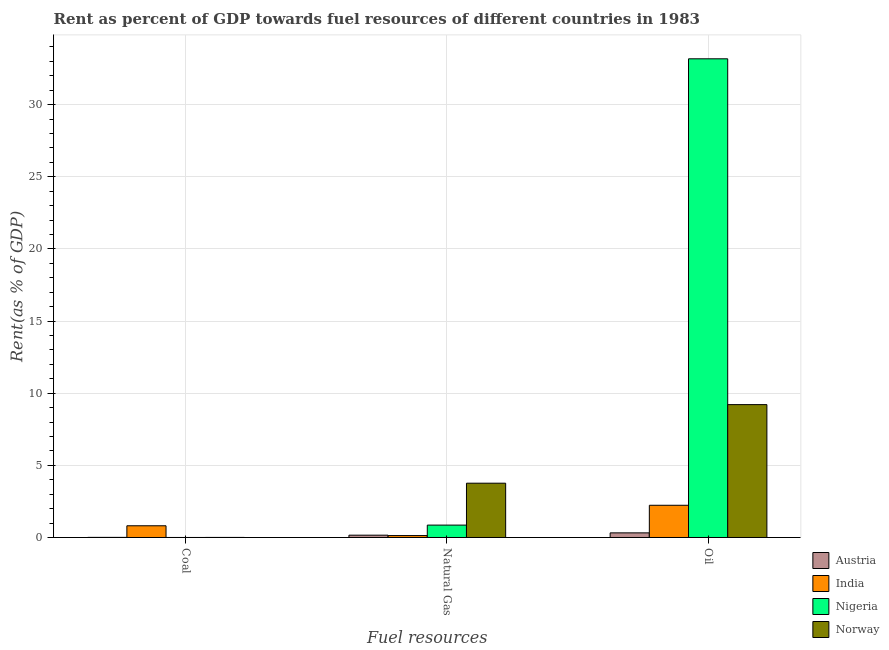How many different coloured bars are there?
Ensure brevity in your answer.  4. How many groups of bars are there?
Offer a terse response. 3. Are the number of bars per tick equal to the number of legend labels?
Your answer should be compact. Yes. How many bars are there on the 3rd tick from the left?
Make the answer very short. 4. What is the label of the 2nd group of bars from the left?
Your answer should be very brief. Natural Gas. What is the rent towards natural gas in Nigeria?
Your response must be concise. 0.86. Across all countries, what is the maximum rent towards coal?
Ensure brevity in your answer.  0.81. Across all countries, what is the minimum rent towards oil?
Give a very brief answer. 0.32. In which country was the rent towards oil maximum?
Offer a very short reply. Nigeria. What is the total rent towards natural gas in the graph?
Offer a very short reply. 4.91. What is the difference between the rent towards natural gas in Austria and that in Nigeria?
Provide a short and direct response. -0.7. What is the difference between the rent towards natural gas in Norway and the rent towards oil in Nigeria?
Give a very brief answer. -29.41. What is the average rent towards oil per country?
Keep it short and to the point. 11.23. What is the difference between the rent towards coal and rent towards natural gas in India?
Give a very brief answer. 0.68. In how many countries, is the rent towards oil greater than 32 %?
Provide a succinct answer. 1. What is the ratio of the rent towards coal in Norway to that in Nigeria?
Offer a very short reply. 3.17. Is the difference between the rent towards coal in Norway and India greater than the difference between the rent towards natural gas in Norway and India?
Give a very brief answer. No. What is the difference between the highest and the second highest rent towards oil?
Offer a terse response. 23.96. What is the difference between the highest and the lowest rent towards coal?
Ensure brevity in your answer.  0.81. What does the 2nd bar from the right in Oil represents?
Ensure brevity in your answer.  Nigeria. Is it the case that in every country, the sum of the rent towards coal and rent towards natural gas is greater than the rent towards oil?
Your answer should be very brief. No. How many bars are there?
Make the answer very short. 12. Are all the bars in the graph horizontal?
Offer a very short reply. No. How many countries are there in the graph?
Ensure brevity in your answer.  4. Are the values on the major ticks of Y-axis written in scientific E-notation?
Your response must be concise. No. How many legend labels are there?
Offer a terse response. 4. What is the title of the graph?
Your answer should be very brief. Rent as percent of GDP towards fuel resources of different countries in 1983. What is the label or title of the X-axis?
Offer a terse response. Fuel resources. What is the label or title of the Y-axis?
Keep it short and to the point. Rent(as % of GDP). What is the Rent(as % of GDP) of Austria in Coal?
Keep it short and to the point. 0.01. What is the Rent(as % of GDP) in India in Coal?
Ensure brevity in your answer.  0.81. What is the Rent(as % of GDP) in Nigeria in Coal?
Give a very brief answer. 0. What is the Rent(as % of GDP) in Norway in Coal?
Keep it short and to the point. 0. What is the Rent(as % of GDP) in Austria in Natural Gas?
Your answer should be very brief. 0.16. What is the Rent(as % of GDP) in India in Natural Gas?
Make the answer very short. 0.13. What is the Rent(as % of GDP) in Nigeria in Natural Gas?
Offer a terse response. 0.86. What is the Rent(as % of GDP) of Norway in Natural Gas?
Provide a short and direct response. 3.76. What is the Rent(as % of GDP) of Austria in Oil?
Provide a short and direct response. 0.32. What is the Rent(as % of GDP) of India in Oil?
Provide a succinct answer. 2.23. What is the Rent(as % of GDP) of Nigeria in Oil?
Make the answer very short. 33.17. What is the Rent(as % of GDP) of Norway in Oil?
Your answer should be compact. 9.21. Across all Fuel resources, what is the maximum Rent(as % of GDP) of Austria?
Your response must be concise. 0.32. Across all Fuel resources, what is the maximum Rent(as % of GDP) of India?
Provide a succinct answer. 2.23. Across all Fuel resources, what is the maximum Rent(as % of GDP) in Nigeria?
Keep it short and to the point. 33.17. Across all Fuel resources, what is the maximum Rent(as % of GDP) of Norway?
Ensure brevity in your answer.  9.21. Across all Fuel resources, what is the minimum Rent(as % of GDP) in Austria?
Offer a very short reply. 0.01. Across all Fuel resources, what is the minimum Rent(as % of GDP) in India?
Provide a succinct answer. 0.13. Across all Fuel resources, what is the minimum Rent(as % of GDP) in Nigeria?
Your answer should be very brief. 0. Across all Fuel resources, what is the minimum Rent(as % of GDP) in Norway?
Give a very brief answer. 0. What is the total Rent(as % of GDP) in Austria in the graph?
Your answer should be very brief. 0.49. What is the total Rent(as % of GDP) of India in the graph?
Keep it short and to the point. 3.18. What is the total Rent(as % of GDP) of Nigeria in the graph?
Provide a short and direct response. 34.03. What is the total Rent(as % of GDP) in Norway in the graph?
Offer a very short reply. 12.98. What is the difference between the Rent(as % of GDP) of Austria in Coal and that in Natural Gas?
Provide a succinct answer. -0.15. What is the difference between the Rent(as % of GDP) in India in Coal and that in Natural Gas?
Your answer should be compact. 0.68. What is the difference between the Rent(as % of GDP) of Nigeria in Coal and that in Natural Gas?
Offer a terse response. -0.86. What is the difference between the Rent(as % of GDP) of Norway in Coal and that in Natural Gas?
Keep it short and to the point. -3.76. What is the difference between the Rent(as % of GDP) of Austria in Coal and that in Oil?
Your response must be concise. -0.31. What is the difference between the Rent(as % of GDP) of India in Coal and that in Oil?
Your answer should be very brief. -1.42. What is the difference between the Rent(as % of GDP) in Nigeria in Coal and that in Oil?
Give a very brief answer. -33.17. What is the difference between the Rent(as % of GDP) in Norway in Coal and that in Oil?
Offer a very short reply. -9.2. What is the difference between the Rent(as % of GDP) of Austria in Natural Gas and that in Oil?
Provide a short and direct response. -0.16. What is the difference between the Rent(as % of GDP) in India in Natural Gas and that in Oil?
Give a very brief answer. -2.1. What is the difference between the Rent(as % of GDP) of Nigeria in Natural Gas and that in Oil?
Make the answer very short. -32.31. What is the difference between the Rent(as % of GDP) in Norway in Natural Gas and that in Oil?
Provide a short and direct response. -5.45. What is the difference between the Rent(as % of GDP) of Austria in Coal and the Rent(as % of GDP) of India in Natural Gas?
Give a very brief answer. -0.13. What is the difference between the Rent(as % of GDP) of Austria in Coal and the Rent(as % of GDP) of Nigeria in Natural Gas?
Your answer should be compact. -0.85. What is the difference between the Rent(as % of GDP) of Austria in Coal and the Rent(as % of GDP) of Norway in Natural Gas?
Make the answer very short. -3.76. What is the difference between the Rent(as % of GDP) of India in Coal and the Rent(as % of GDP) of Nigeria in Natural Gas?
Your answer should be very brief. -0.05. What is the difference between the Rent(as % of GDP) in India in Coal and the Rent(as % of GDP) in Norway in Natural Gas?
Give a very brief answer. -2.95. What is the difference between the Rent(as % of GDP) of Nigeria in Coal and the Rent(as % of GDP) of Norway in Natural Gas?
Your answer should be very brief. -3.76. What is the difference between the Rent(as % of GDP) in Austria in Coal and the Rent(as % of GDP) in India in Oil?
Keep it short and to the point. -2.23. What is the difference between the Rent(as % of GDP) of Austria in Coal and the Rent(as % of GDP) of Nigeria in Oil?
Provide a succinct answer. -33.17. What is the difference between the Rent(as % of GDP) in Austria in Coal and the Rent(as % of GDP) in Norway in Oil?
Ensure brevity in your answer.  -9.2. What is the difference between the Rent(as % of GDP) of India in Coal and the Rent(as % of GDP) of Nigeria in Oil?
Make the answer very short. -32.36. What is the difference between the Rent(as % of GDP) of India in Coal and the Rent(as % of GDP) of Norway in Oil?
Your response must be concise. -8.4. What is the difference between the Rent(as % of GDP) of Nigeria in Coal and the Rent(as % of GDP) of Norway in Oil?
Offer a terse response. -9.21. What is the difference between the Rent(as % of GDP) in Austria in Natural Gas and the Rent(as % of GDP) in India in Oil?
Your response must be concise. -2.07. What is the difference between the Rent(as % of GDP) of Austria in Natural Gas and the Rent(as % of GDP) of Nigeria in Oil?
Offer a terse response. -33.01. What is the difference between the Rent(as % of GDP) in Austria in Natural Gas and the Rent(as % of GDP) in Norway in Oil?
Ensure brevity in your answer.  -9.05. What is the difference between the Rent(as % of GDP) of India in Natural Gas and the Rent(as % of GDP) of Nigeria in Oil?
Offer a terse response. -33.04. What is the difference between the Rent(as % of GDP) in India in Natural Gas and the Rent(as % of GDP) in Norway in Oil?
Your answer should be very brief. -9.08. What is the difference between the Rent(as % of GDP) of Nigeria in Natural Gas and the Rent(as % of GDP) of Norway in Oil?
Make the answer very short. -8.35. What is the average Rent(as % of GDP) in Austria per Fuel resources?
Offer a terse response. 0.16. What is the average Rent(as % of GDP) of India per Fuel resources?
Your response must be concise. 1.06. What is the average Rent(as % of GDP) of Nigeria per Fuel resources?
Your answer should be very brief. 11.34. What is the average Rent(as % of GDP) in Norway per Fuel resources?
Offer a very short reply. 4.33. What is the difference between the Rent(as % of GDP) of Austria and Rent(as % of GDP) of India in Coal?
Keep it short and to the point. -0.8. What is the difference between the Rent(as % of GDP) in Austria and Rent(as % of GDP) in Nigeria in Coal?
Ensure brevity in your answer.  0.01. What is the difference between the Rent(as % of GDP) in Austria and Rent(as % of GDP) in Norway in Coal?
Make the answer very short. 0. What is the difference between the Rent(as % of GDP) in India and Rent(as % of GDP) in Nigeria in Coal?
Give a very brief answer. 0.81. What is the difference between the Rent(as % of GDP) in India and Rent(as % of GDP) in Norway in Coal?
Make the answer very short. 0.81. What is the difference between the Rent(as % of GDP) of Nigeria and Rent(as % of GDP) of Norway in Coal?
Your response must be concise. -0. What is the difference between the Rent(as % of GDP) in Austria and Rent(as % of GDP) in India in Natural Gas?
Your response must be concise. 0.03. What is the difference between the Rent(as % of GDP) of Austria and Rent(as % of GDP) of Nigeria in Natural Gas?
Ensure brevity in your answer.  -0.7. What is the difference between the Rent(as % of GDP) of Austria and Rent(as % of GDP) of Norway in Natural Gas?
Keep it short and to the point. -3.6. What is the difference between the Rent(as % of GDP) in India and Rent(as % of GDP) in Nigeria in Natural Gas?
Your response must be concise. -0.73. What is the difference between the Rent(as % of GDP) in India and Rent(as % of GDP) in Norway in Natural Gas?
Ensure brevity in your answer.  -3.63. What is the difference between the Rent(as % of GDP) of Nigeria and Rent(as % of GDP) of Norway in Natural Gas?
Your answer should be very brief. -2.9. What is the difference between the Rent(as % of GDP) of Austria and Rent(as % of GDP) of India in Oil?
Keep it short and to the point. -1.91. What is the difference between the Rent(as % of GDP) of Austria and Rent(as % of GDP) of Nigeria in Oil?
Your response must be concise. -32.85. What is the difference between the Rent(as % of GDP) in Austria and Rent(as % of GDP) in Norway in Oil?
Ensure brevity in your answer.  -8.89. What is the difference between the Rent(as % of GDP) in India and Rent(as % of GDP) in Nigeria in Oil?
Offer a very short reply. -30.94. What is the difference between the Rent(as % of GDP) of India and Rent(as % of GDP) of Norway in Oil?
Provide a short and direct response. -6.98. What is the difference between the Rent(as % of GDP) in Nigeria and Rent(as % of GDP) in Norway in Oil?
Give a very brief answer. 23.96. What is the ratio of the Rent(as % of GDP) of Austria in Coal to that in Natural Gas?
Your answer should be compact. 0.04. What is the ratio of the Rent(as % of GDP) of India in Coal to that in Natural Gas?
Ensure brevity in your answer.  6.12. What is the ratio of the Rent(as % of GDP) in Nigeria in Coal to that in Natural Gas?
Offer a very short reply. 0. What is the ratio of the Rent(as % of GDP) of Norway in Coal to that in Natural Gas?
Make the answer very short. 0. What is the ratio of the Rent(as % of GDP) in Austria in Coal to that in Oil?
Ensure brevity in your answer.  0.02. What is the ratio of the Rent(as % of GDP) in India in Coal to that in Oil?
Offer a very short reply. 0.36. What is the ratio of the Rent(as % of GDP) in Nigeria in Coal to that in Oil?
Ensure brevity in your answer.  0. What is the ratio of the Rent(as % of GDP) in Austria in Natural Gas to that in Oil?
Your answer should be very brief. 0.5. What is the ratio of the Rent(as % of GDP) in India in Natural Gas to that in Oil?
Keep it short and to the point. 0.06. What is the ratio of the Rent(as % of GDP) of Nigeria in Natural Gas to that in Oil?
Give a very brief answer. 0.03. What is the ratio of the Rent(as % of GDP) in Norway in Natural Gas to that in Oil?
Offer a very short reply. 0.41. What is the difference between the highest and the second highest Rent(as % of GDP) in Austria?
Give a very brief answer. 0.16. What is the difference between the highest and the second highest Rent(as % of GDP) of India?
Your answer should be compact. 1.42. What is the difference between the highest and the second highest Rent(as % of GDP) in Nigeria?
Offer a very short reply. 32.31. What is the difference between the highest and the second highest Rent(as % of GDP) of Norway?
Provide a succinct answer. 5.45. What is the difference between the highest and the lowest Rent(as % of GDP) in Austria?
Your answer should be compact. 0.31. What is the difference between the highest and the lowest Rent(as % of GDP) in India?
Ensure brevity in your answer.  2.1. What is the difference between the highest and the lowest Rent(as % of GDP) in Nigeria?
Ensure brevity in your answer.  33.17. What is the difference between the highest and the lowest Rent(as % of GDP) in Norway?
Provide a short and direct response. 9.2. 